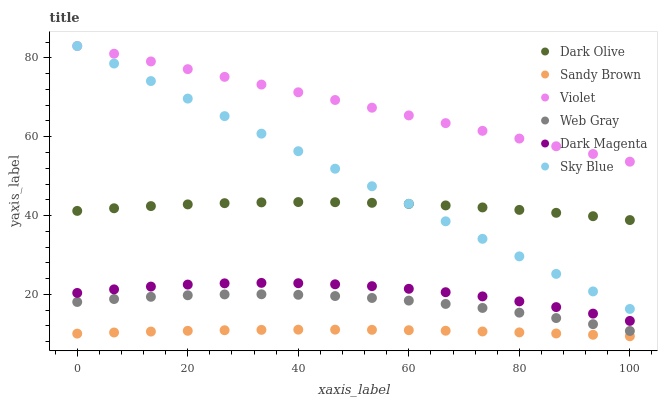Does Sandy Brown have the minimum area under the curve?
Answer yes or no. Yes. Does Violet have the maximum area under the curve?
Answer yes or no. Yes. Does Dark Magenta have the minimum area under the curve?
Answer yes or no. No. Does Dark Magenta have the maximum area under the curve?
Answer yes or no. No. Is Violet the smoothest?
Answer yes or no. Yes. Is Dark Magenta the roughest?
Answer yes or no. Yes. Is Dark Olive the smoothest?
Answer yes or no. No. Is Dark Olive the roughest?
Answer yes or no. No. Does Sandy Brown have the lowest value?
Answer yes or no. Yes. Does Dark Magenta have the lowest value?
Answer yes or no. No. Does Sky Blue have the highest value?
Answer yes or no. Yes. Does Dark Magenta have the highest value?
Answer yes or no. No. Is Dark Magenta less than Dark Olive?
Answer yes or no. Yes. Is Dark Magenta greater than Web Gray?
Answer yes or no. Yes. Does Sky Blue intersect Dark Olive?
Answer yes or no. Yes. Is Sky Blue less than Dark Olive?
Answer yes or no. No. Is Sky Blue greater than Dark Olive?
Answer yes or no. No. Does Dark Magenta intersect Dark Olive?
Answer yes or no. No. 